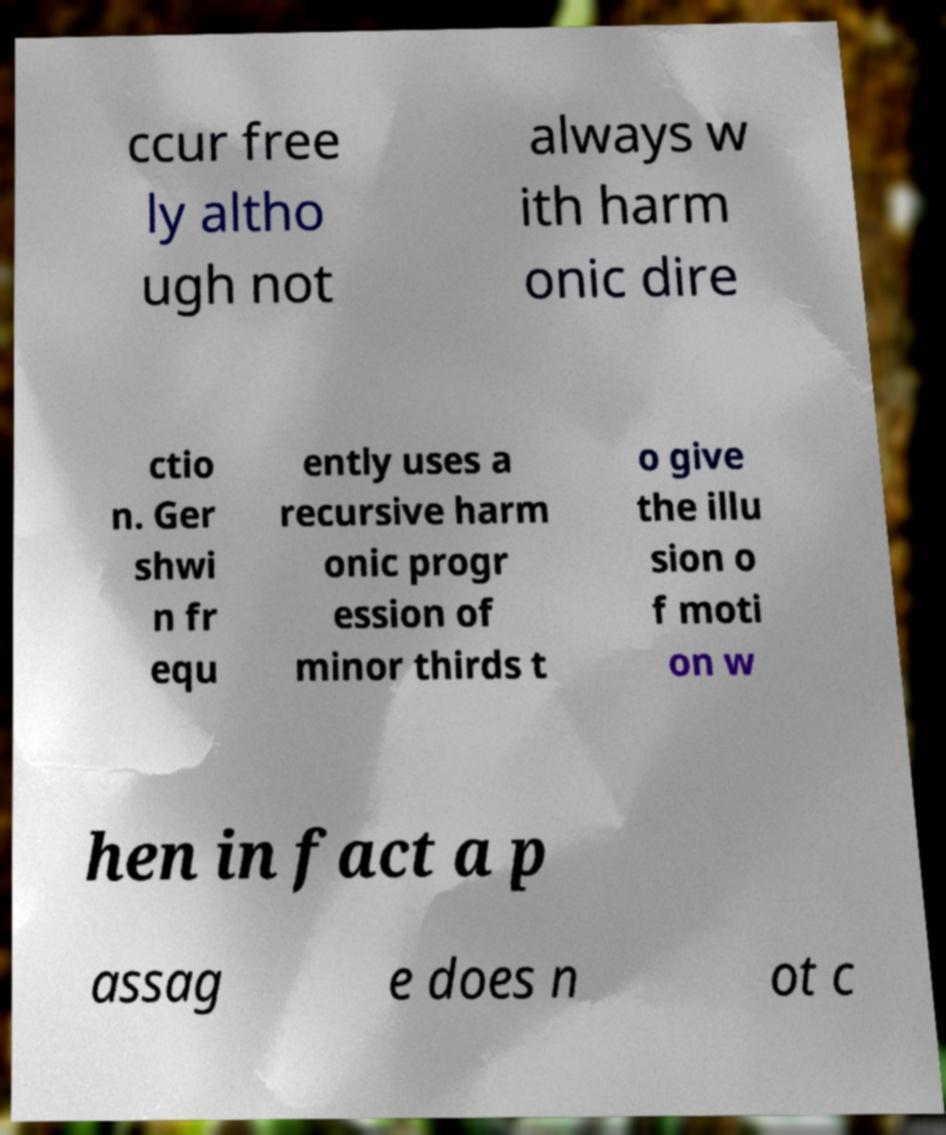For documentation purposes, I need the text within this image transcribed. Could you provide that? ccur free ly altho ugh not always w ith harm onic dire ctio n. Ger shwi n fr equ ently uses a recursive harm onic progr ession of minor thirds t o give the illu sion o f moti on w hen in fact a p assag e does n ot c 